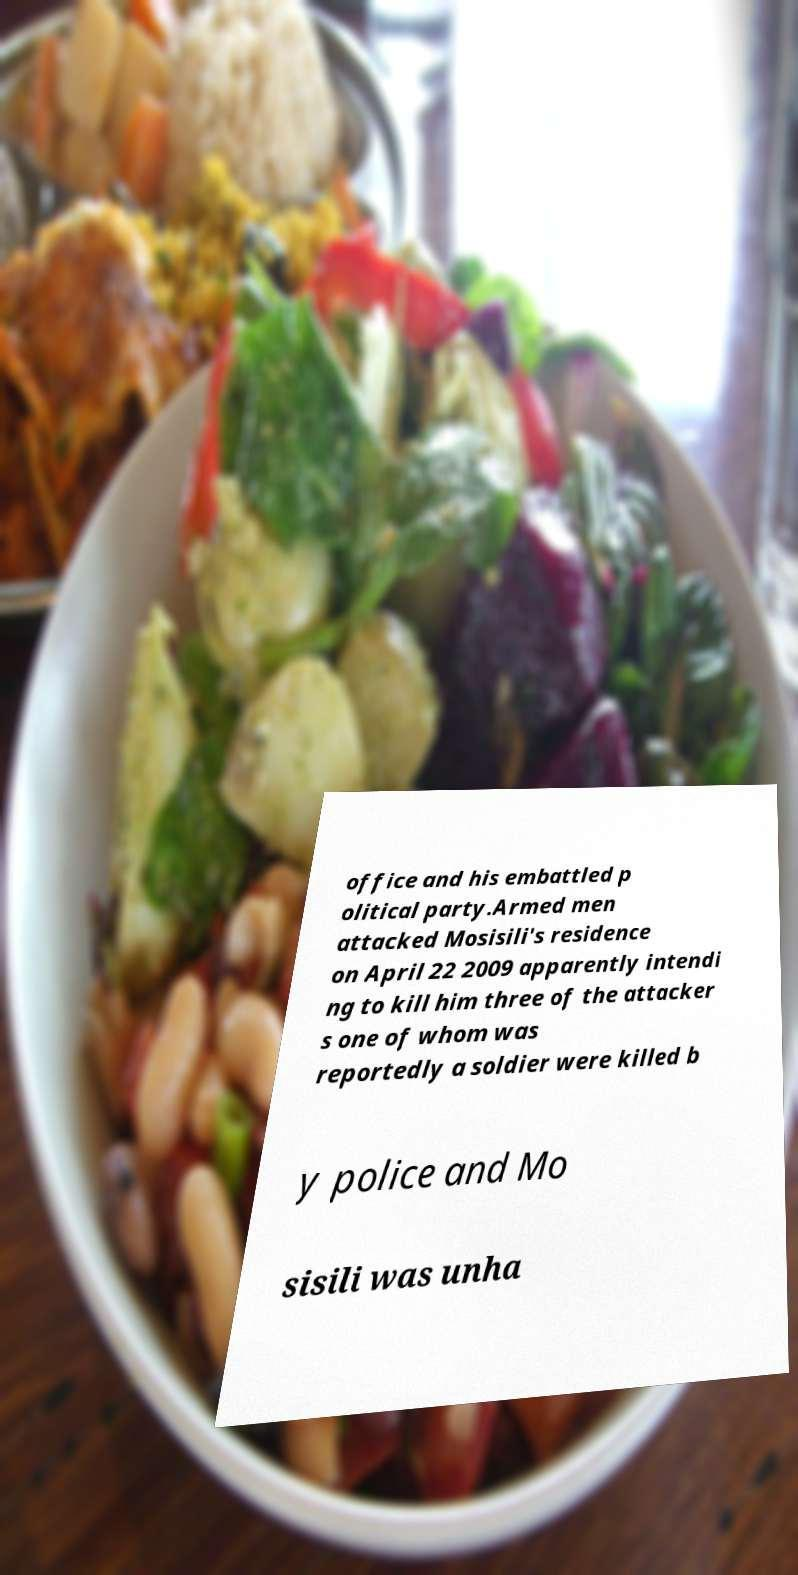What messages or text are displayed in this image? I need them in a readable, typed format. office and his embattled p olitical party.Armed men attacked Mosisili's residence on April 22 2009 apparently intendi ng to kill him three of the attacker s one of whom was reportedly a soldier were killed b y police and Mo sisili was unha 